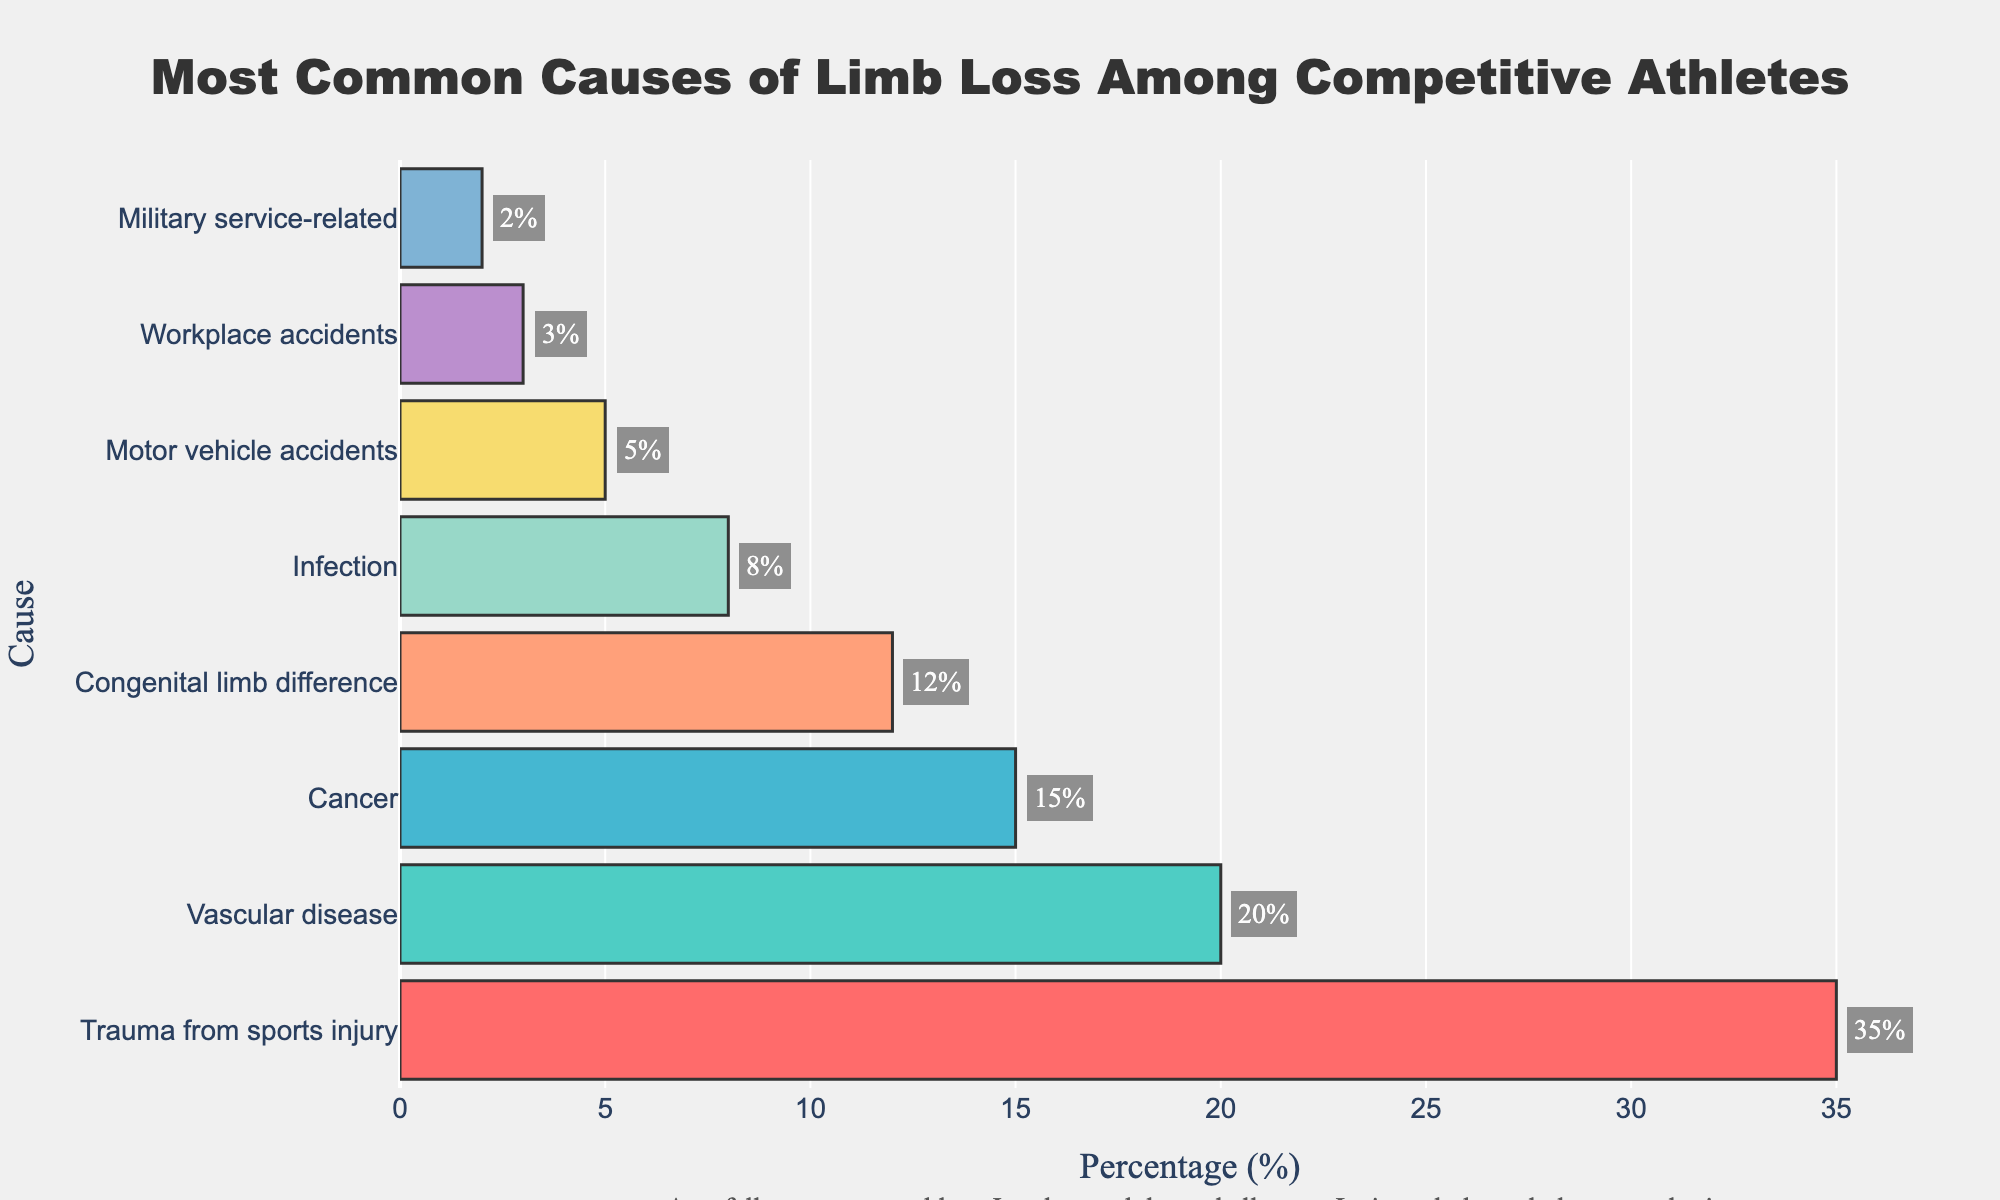What is the most common cause of limb loss among competitive athletes? The figure shows that "Trauma from sports injury" has the highest percentage bar among all causes.
Answer: Trauma from sports injury Which cause of limb loss has the smallest percentage among competitive athletes? The smallest bar corresponds to "Military service-related," which has the last position with the lowest percentage.
Answer: Military service-related How much higher is the percentage of limb loss due to trauma from sports injury compared to motor vehicle accidents? Trauma from sports injury has a percentage of 35%, while motor vehicle accidents have 5%. The difference is 35% - 5%.
Answer: 30% Which color bar represents limb loss due to cancer, and what is its percentage? The bar representing "Cancer" is the fourth from the top, colored in blue, with a percentage of 15%.
Answer: Blue, 15% What is the combined percentage of limb loss due to vascular disease and infection? Vascular disease has a percentage of 20%, and infection has 8%. The combined percentage is 20% + 8%.
Answer: 28% Is the percentage of limb loss due to congenital limb difference greater than or less than that due to cancer? The percentage for congenital limb difference is 12%, and for cancer, it is 15%. Therefore, 12% is less than 15%.
Answer: Less than Which cause has a percentage that is equal to the combined percentage of workplace accidents and military service-related? Workplace accidents have 3%, and military service-related has 2%. The combined percentage is 3% + 2% = 5%. Motor vehicle accidents also stand at 5%.
Answer: Motor vehicle accidents What is the average percentage of limb loss for all causes? To find the average, sum all the percentages (35% + 20% + 15% + 12% + 8% + 5% + 3% + 2%) and divide by the number of causes (8). (35 + 20 + 15 + 12 + 8 + 5 + 3 + 2) / 8 = 100 / 8.
Answer: 12.5% Which cause has a percentage closest to the average percentage of limb loss among all causes? The calculated average is 12.5%. The percentages of causes are closest for "Congenital limb difference" at 12% and "Infection" at 8%. 12% is closer to 12.5% than 8%.
Answer: Congenital limb difference 